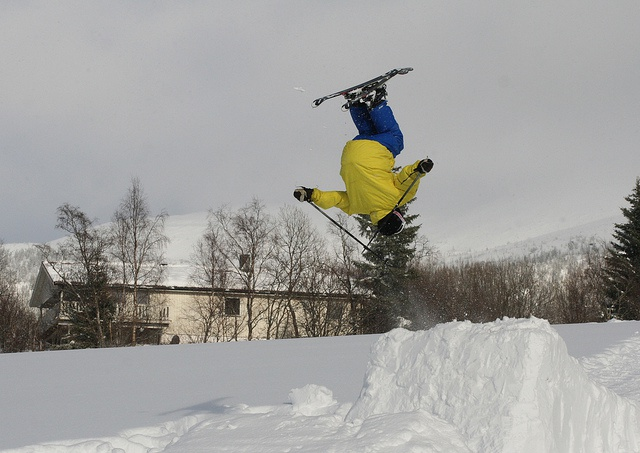Describe the objects in this image and their specific colors. I can see people in darkgray, olive, black, and navy tones and skis in darkgray, black, gray, and lightgray tones in this image. 